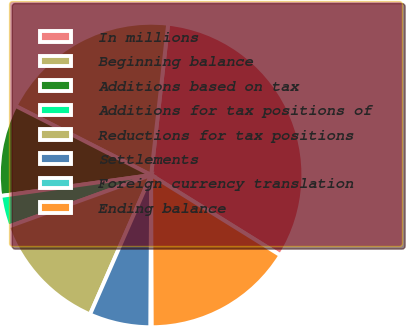<chart> <loc_0><loc_0><loc_500><loc_500><pie_chart><fcel>In millions<fcel>Beginning balance<fcel>Additions based on tax<fcel>Additions for tax positions of<fcel>Reductions for tax positions<fcel>Settlements<fcel>Foreign currency translation<fcel>Ending balance<nl><fcel>32.06%<fcel>19.29%<fcel>9.71%<fcel>3.32%<fcel>12.9%<fcel>6.51%<fcel>0.13%<fcel>16.09%<nl></chart> 